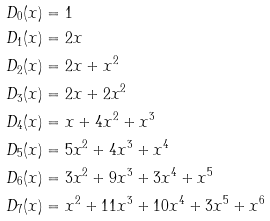Convert formula to latex. <formula><loc_0><loc_0><loc_500><loc_500>D _ { 0 } ( x ) & = 1 \\ D _ { 1 } ( x ) & = 2 x \\ D _ { 2 } ( x ) & = 2 x + x ^ { 2 } \\ D _ { 3 } ( x ) & = 2 x + 2 x ^ { 2 } \\ D _ { 4 } ( x ) & = x + 4 x ^ { 2 } + x ^ { 3 } \\ D _ { 5 } ( x ) & = 5 x ^ { 2 } + 4 x ^ { 3 } + x ^ { 4 } \\ D _ { 6 } ( x ) & = 3 x ^ { 2 } + 9 x ^ { 3 } + 3 x ^ { 4 } + x ^ { 5 } \\ D _ { 7 } ( x ) & = x ^ { 2 } + 1 1 x ^ { 3 } + 1 0 x ^ { 4 } + 3 x ^ { 5 } + x ^ { 6 } \\</formula> 